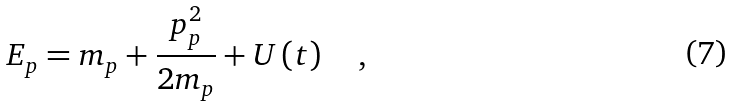<formula> <loc_0><loc_0><loc_500><loc_500>E _ { p } = m _ { p } + \frac { p _ { p } ^ { 2 } } { 2 m _ { p } } + U \left ( t \right ) \quad ,</formula> 